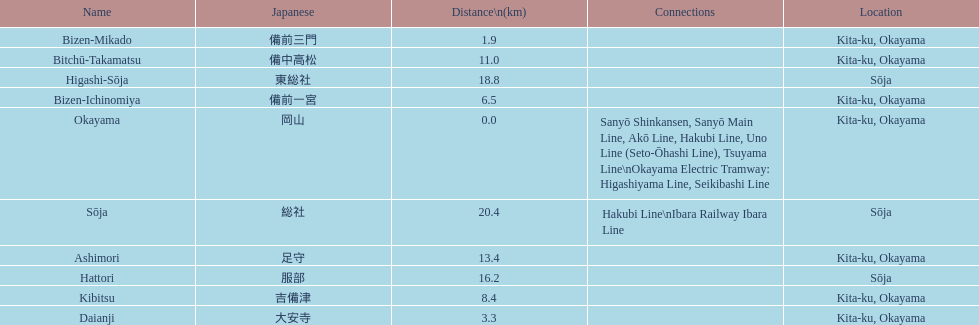How many station are located in kita-ku, okayama? 7. Parse the table in full. {'header': ['Name', 'Japanese', 'Distance\\n(km)', 'Connections', 'Location'], 'rows': [['Bizen-Mikado', '備前三門', '1.9', '', 'Kita-ku, Okayama'], ['Bitchū-Takamatsu', '備中高松', '11.0', '', 'Kita-ku, Okayama'], ['Higashi-Sōja', '東総社', '18.8', '', 'Sōja'], ['Bizen-Ichinomiya', '備前一宮', '6.5', '', 'Kita-ku, Okayama'], ['Okayama', '岡山', '0.0', 'Sanyō Shinkansen, Sanyō Main Line, Akō Line, Hakubi Line, Uno Line (Seto-Ōhashi Line), Tsuyama Line\\nOkayama Electric Tramway: Higashiyama Line, Seikibashi Line', 'Kita-ku, Okayama'], ['Sōja', '総社', '20.4', 'Hakubi Line\\nIbara Railway Ibara Line', 'Sōja'], ['Ashimori', '足守', '13.4', '', 'Kita-ku, Okayama'], ['Hattori', '服部', '16.2', '', 'Sōja'], ['Kibitsu', '吉備津', '8.4', '', 'Kita-ku, Okayama'], ['Daianji', '大安寺', '3.3', '', 'Kita-ku, Okayama']]} 